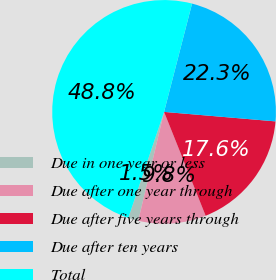Convert chart. <chart><loc_0><loc_0><loc_500><loc_500><pie_chart><fcel>Due in one year or less<fcel>Due after one year through<fcel>Due after five years through<fcel>Due after ten years<fcel>Total<nl><fcel>1.47%<fcel>9.77%<fcel>17.59%<fcel>22.33%<fcel>48.85%<nl></chart> 